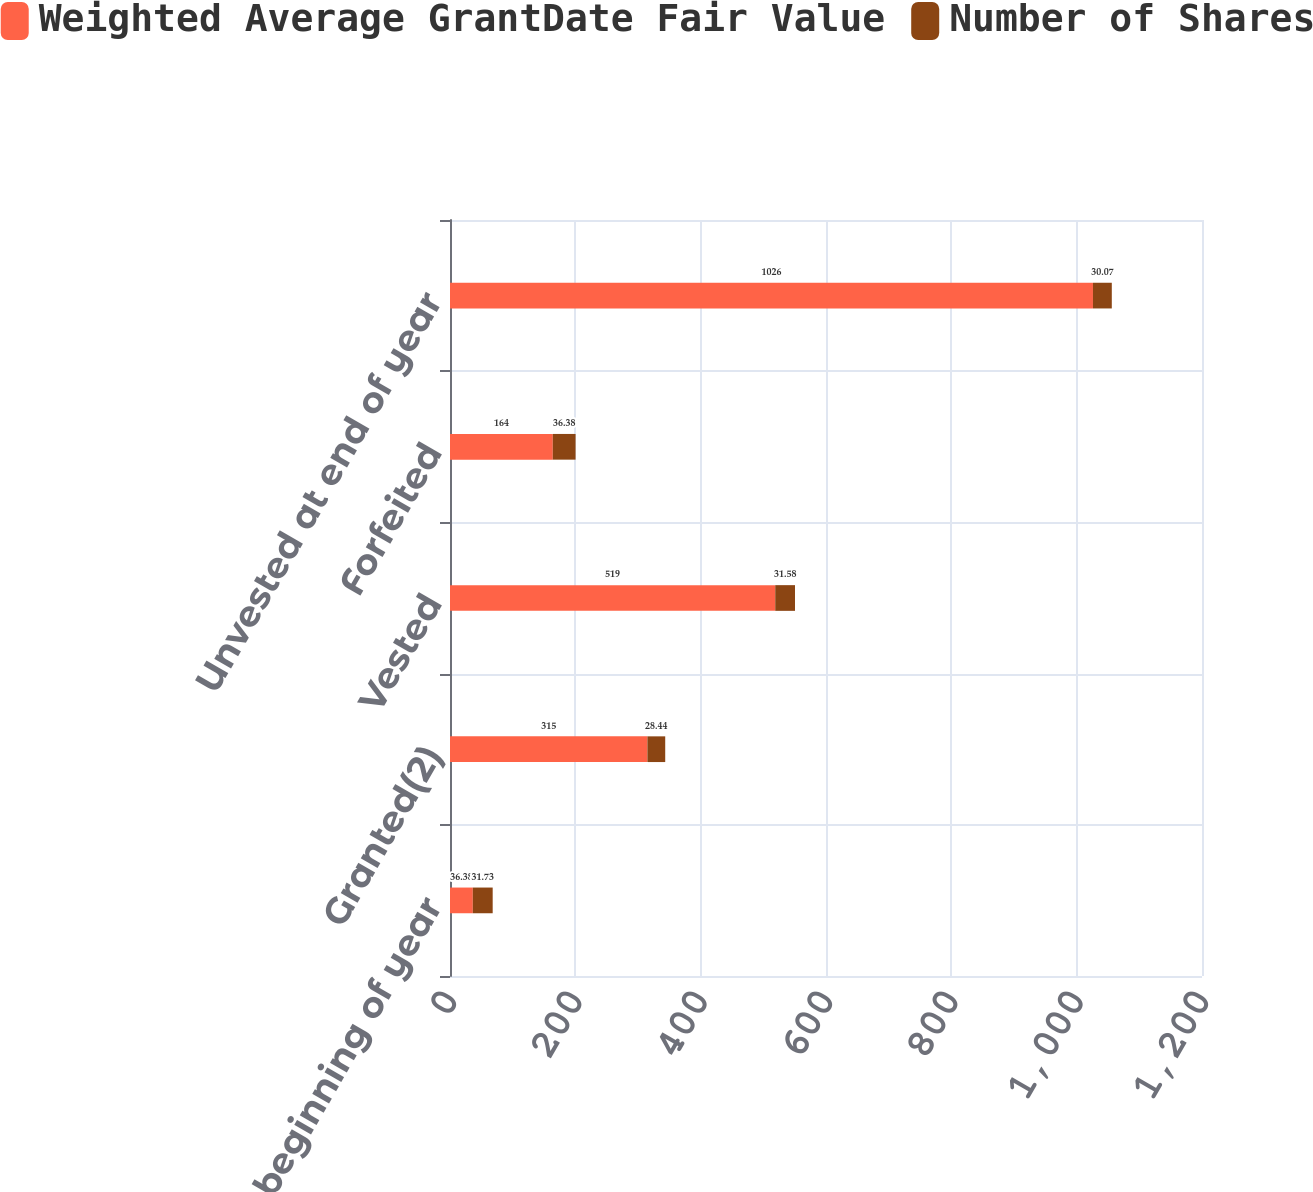<chart> <loc_0><loc_0><loc_500><loc_500><stacked_bar_chart><ecel><fcel>Unvested at beginning of year<fcel>Granted(2)<fcel>Vested<fcel>Forfeited<fcel>Unvested at end of year<nl><fcel>Weighted Average GrantDate Fair Value<fcel>36.38<fcel>315<fcel>519<fcel>164<fcel>1026<nl><fcel>Number of Shares<fcel>31.73<fcel>28.44<fcel>31.58<fcel>36.38<fcel>30.07<nl></chart> 